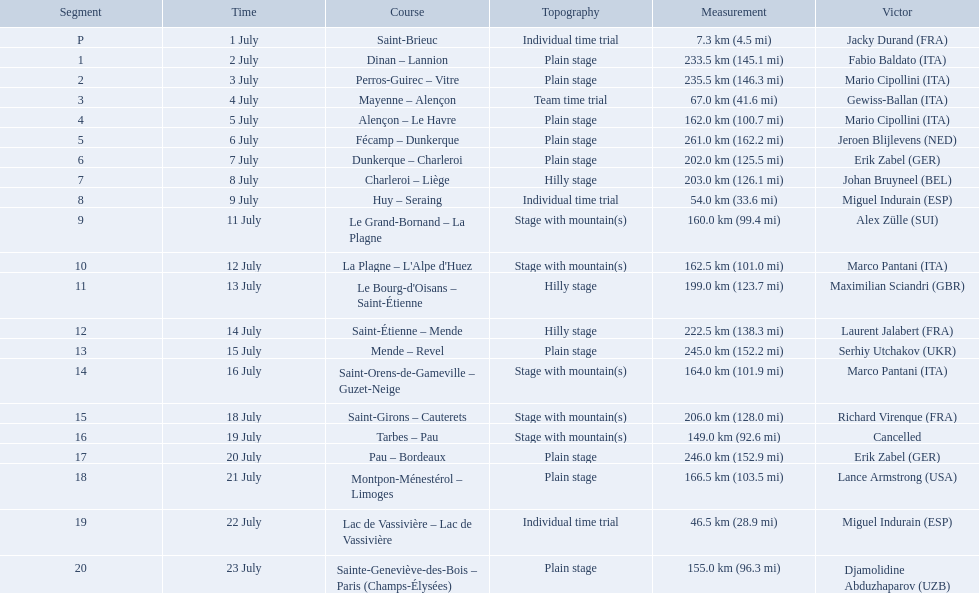What were the dates of the 1995 tour de france? 1 July, 2 July, 3 July, 4 July, 5 July, 6 July, 7 July, 8 July, 9 July, 11 July, 12 July, 13 July, 14 July, 15 July, 16 July, 18 July, 19 July, 20 July, 21 July, 22 July, 23 July. What was the length for july 8th? 203.0 km (126.1 mi). What are the dates? 1 July, 2 July, 3 July, 4 July, 5 July, 6 July, 7 July, 8 July, 9 July, 11 July, 12 July, 13 July, 14 July, 15 July, 16 July, 18 July, 19 July, 20 July, 21 July, 22 July, 23 July. What is the length on 8 july? 203.0 km (126.1 mi). 